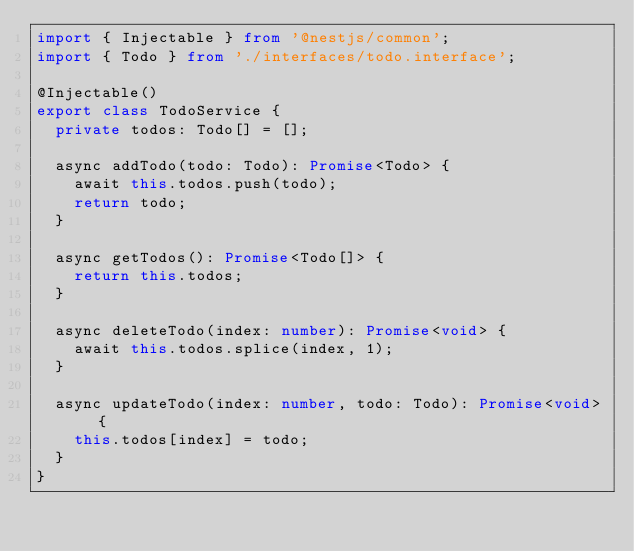Convert code to text. <code><loc_0><loc_0><loc_500><loc_500><_TypeScript_>import { Injectable } from '@nestjs/common';
import { Todo } from './interfaces/todo.interface';

@Injectable()
export class TodoService {
  private todos: Todo[] = [];

  async addTodo(todo: Todo): Promise<Todo> {
    await this.todos.push(todo);
    return todo;
  }

  async getTodos(): Promise<Todo[]> {
    return this.todos;
  }

  async deleteTodo(index: number): Promise<void> {
    await this.todos.splice(index, 1);
  }

  async updateTodo(index: number, todo: Todo): Promise<void> {
    this.todos[index] = todo;
  }
}
</code> 